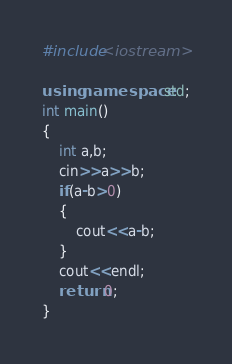Convert code to text. <code><loc_0><loc_0><loc_500><loc_500><_C++_>#include<iostream>

using namespace std;
int main()
{
    int a,b;
    cin>>a>>b;
    if(a-b>0)
    {
        cout<<a-b;
    }
    cout<<endl;
    return 0;
}</code> 